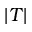<formula> <loc_0><loc_0><loc_500><loc_500>| T |</formula> 